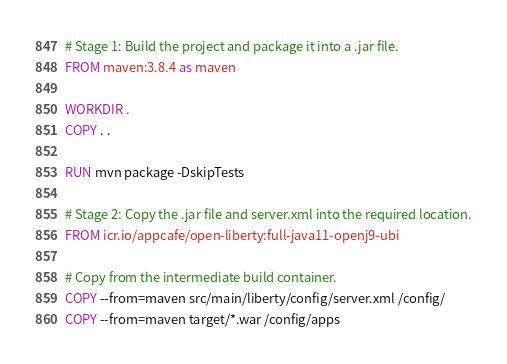Convert code to text. <code><loc_0><loc_0><loc_500><loc_500><_Dockerfile_># Stage 1: Build the project and package it into a .jar file.
FROM maven:3.8.4 as maven

WORKDIR .
COPY . .

RUN mvn package -DskipTests

# Stage 2: Copy the .jar file and server.xml into the required location.
FROM icr.io/appcafe/open-liberty:full-java11-openj9-ubi

# Copy from the intermediate build container.
COPY --from=maven src/main/liberty/config/server.xml /config/
COPY --from=maven target/*.war /config/apps</code> 